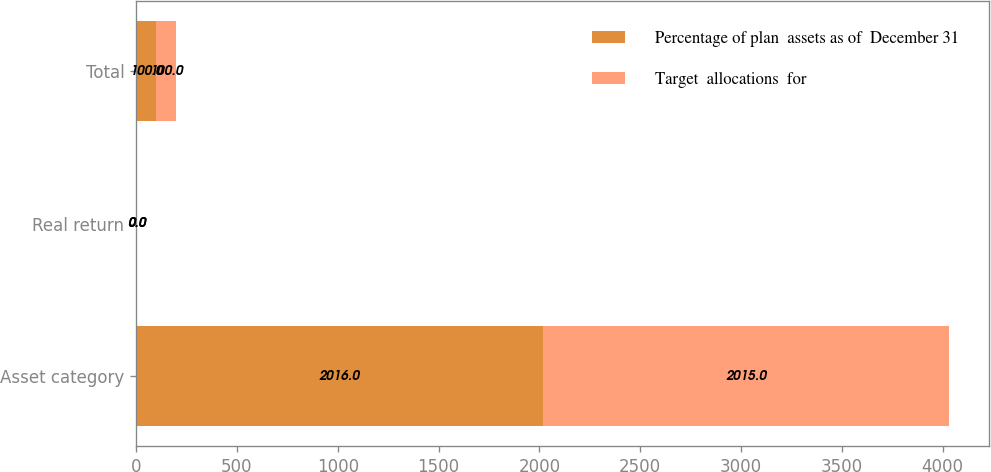Convert chart. <chart><loc_0><loc_0><loc_500><loc_500><stacked_bar_chart><ecel><fcel>Asset category<fcel>Real return<fcel>Total<nl><fcel>Percentage of plan  assets as of  December 31<fcel>2016<fcel>0<fcel>100<nl><fcel>Target  allocations  for<fcel>2015<fcel>0<fcel>100<nl></chart> 